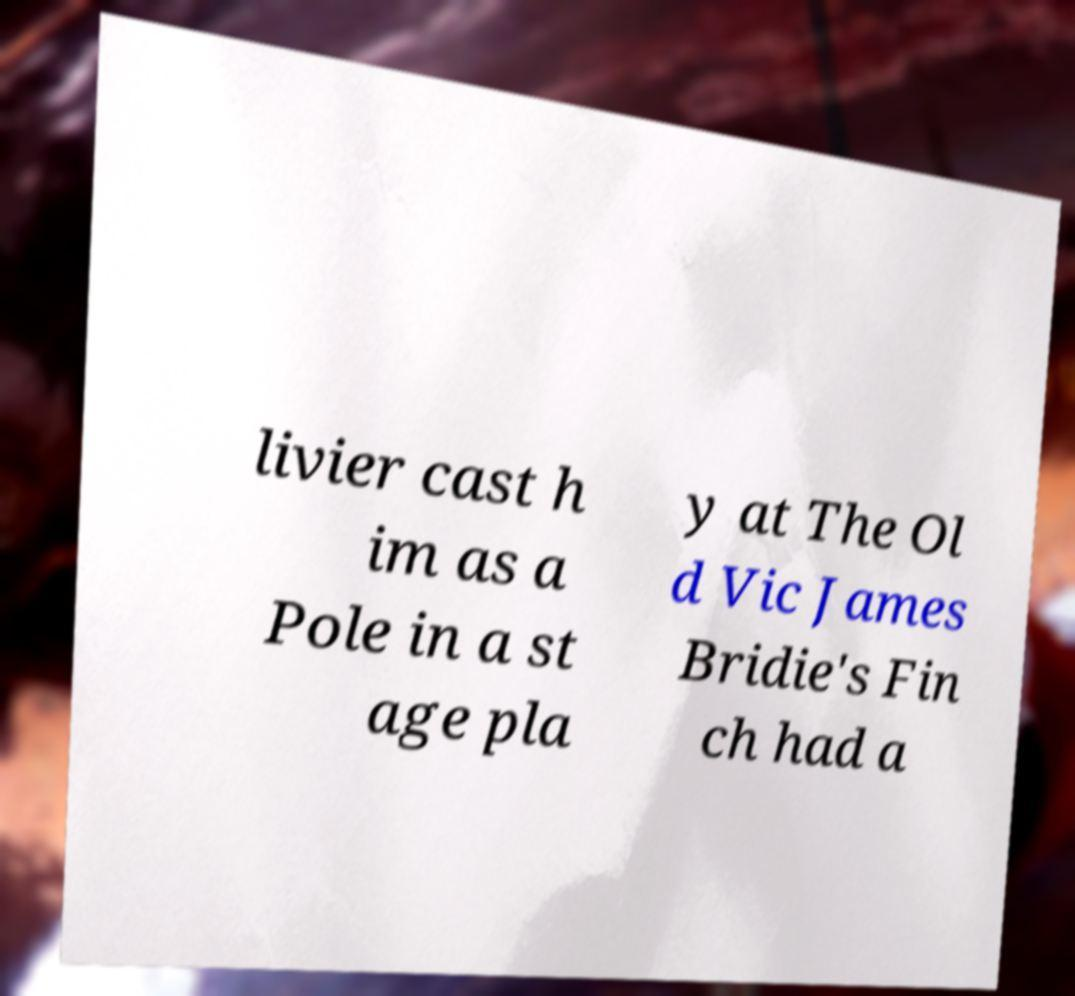Can you accurately transcribe the text from the provided image for me? livier cast h im as a Pole in a st age pla y at The Ol d Vic James Bridie's Fin ch had a 